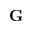<formula> <loc_0><loc_0><loc_500><loc_500>G</formula> 